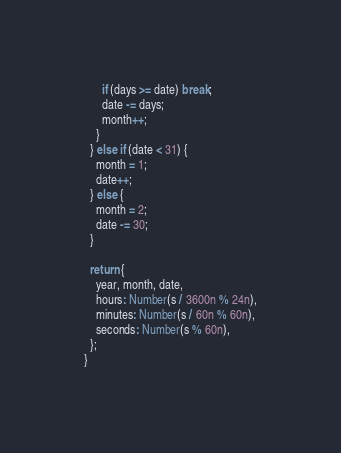Convert code to text. <code><loc_0><loc_0><loc_500><loc_500><_JavaScript_>      if (days >= date) break;
      date -= days;
      month++;
    }
  } else if (date < 31) {
    month = 1;
    date++;
  } else {
    month = 2;
    date -= 30;
  }

  return {
    year, month, date,
    hours: Number(s / 3600n % 24n),
    minutes: Number(s / 60n % 60n),
    seconds: Number(s % 60n),
  };
}
</code> 